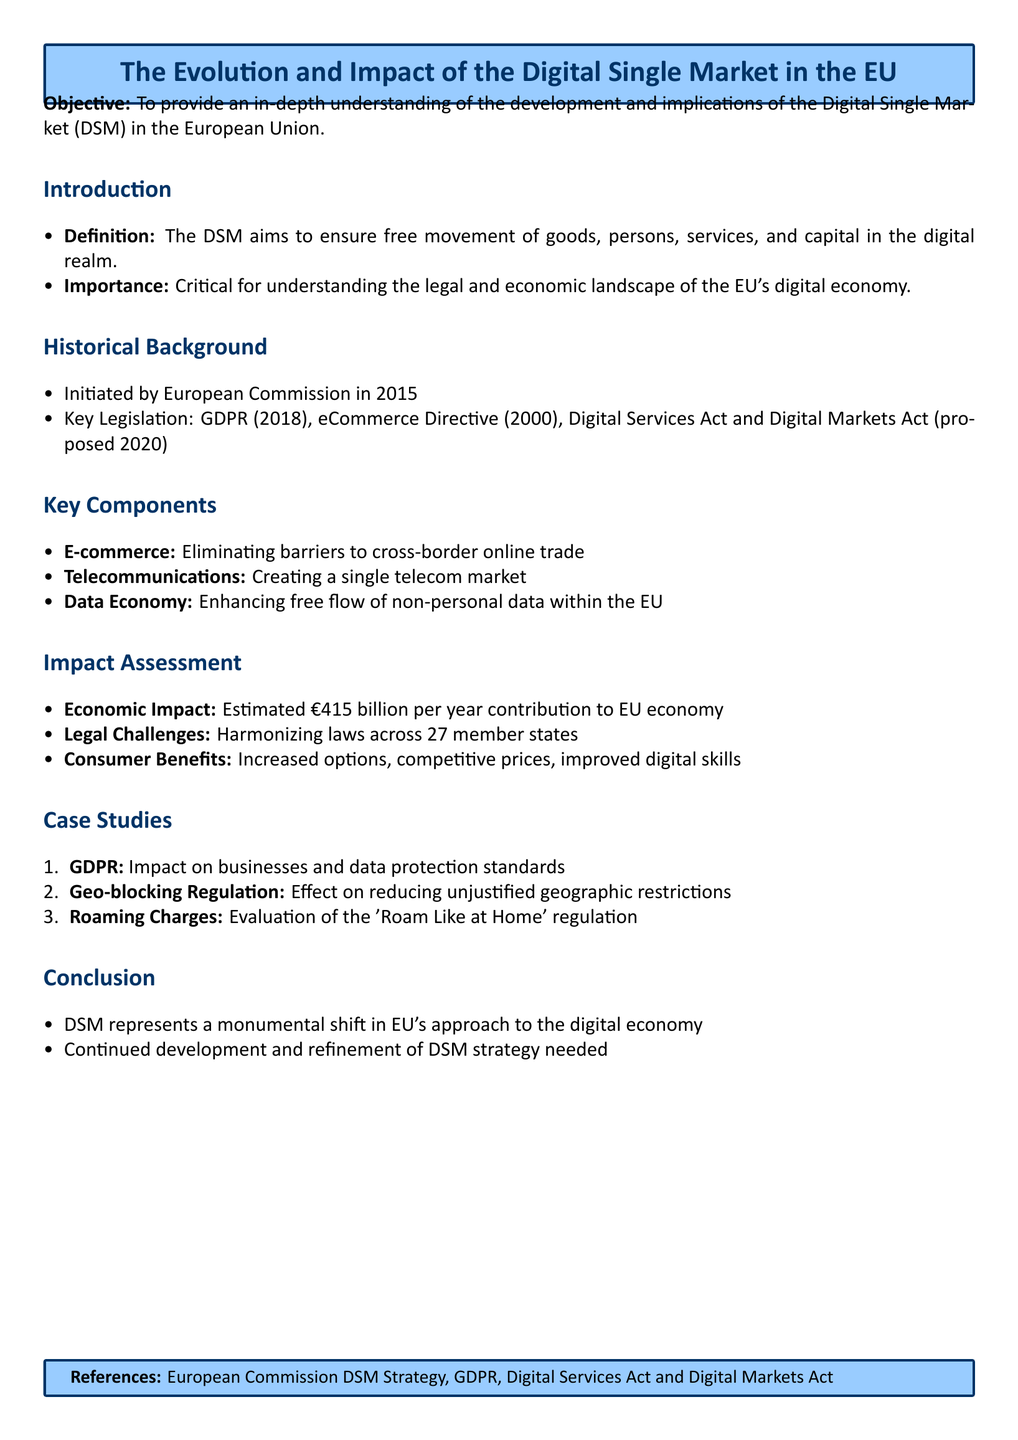What is the objective of the lesson plan? The objective is stated clearly in the document and focuses on the understanding of the Digital Single Market.
Answer: To provide an in-depth understanding of the development and implications of the Digital Single Market (DSM) in the European Union When was the Digital Single Market initiated? The specific year of initiation is mentioned in the historical background section.
Answer: 2015 What legislation is mentioned as key to the Digital Single Market? The lesson outlines key legislation relevant to the DSM, including GDPR and others.
Answer: GDPR (2018), eCommerce Directive (2000), Digital Services Act and Digital Markets Act What is the estimated economic impact of the Digital Single Market? The document provides a specific figure detailing the expected economic contribution.
Answer: €415 billion per year Which regulation affected roaming charges? The case studies section explicitly names the regulation related to roaming charges.
Answer: 'Roam Like at Home' regulation What are two key components of the Digital Single Market? The document lists components that define the DSM, asking for two examples qualifies as retrieval.
Answer: E-commerce, Telecommunications How many member states does the document mention in the context of legal challenges? The number of member states is directly provided in the impact assessment part referring to harmonizing laws.
Answer: 27 What does the conclusion highlight as a necessary action for the Digital Single Market? The conclusion suggests ongoing efforts required for the DSM, which constitutes a reasoning aspect.
Answer: Continued development and refinement of DSM strategy needed 